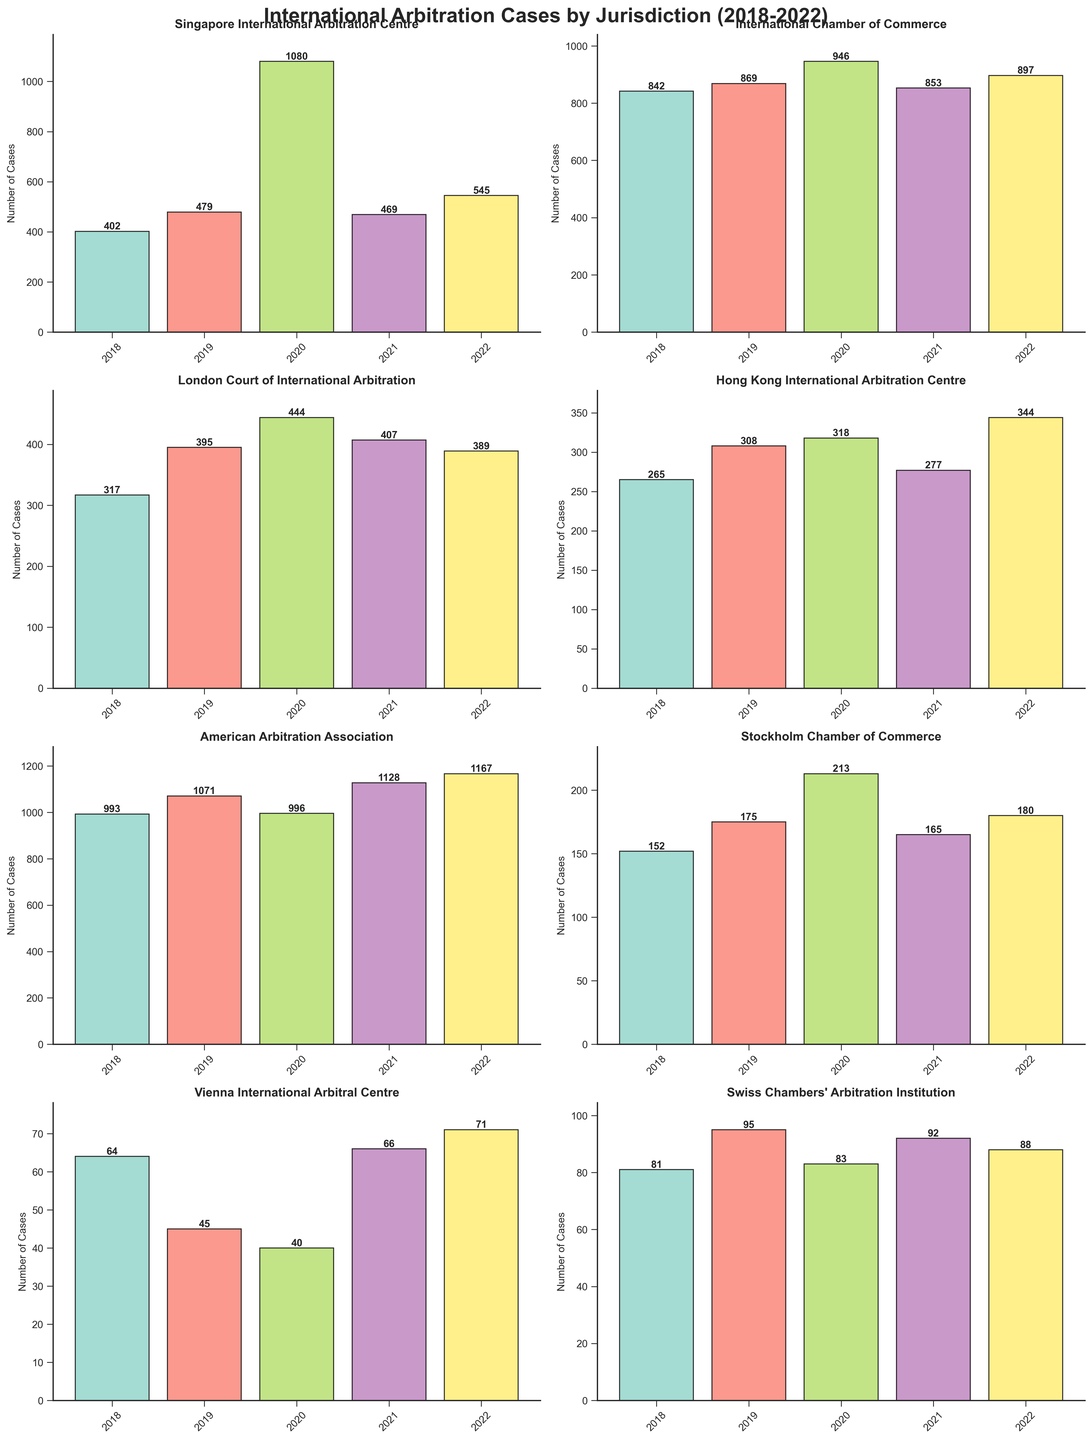What is the title of the figure? The title is usually displayed at the top of the figure. In this case, it is clearly mentioned at the top in bold.
Answer: International Arbitration Cases by Jurisdiction (2018-2022) How many jurisdictions are depicted in the figure? Each subplot represents a different jurisdiction. By counting the number of subplots, we can determine the number of jurisdictions.
Answer: 8 Which jurisdiction had the highest number of arbitration cases in 2022? By examining the 2022 bars in each subplot, the jurisdiction with the highest bar indicates the highest number of arbitration cases.
Answer: American Arbitration Association Which jurisdiction showed the most significant increase in cases from 2019 to 2020? We compare the heights of the bars for 2019 and 2020 for each jurisdiction. The jurisdiction with the largest difference (increase) between these two years shows the most significant increase.
Answer: Singapore International Arbitration Centre What is the average number of cases for the London Court of International Arbitration over the 5 years? To find the average, add the number of cases for each year for the London Court of International Arbitration and divide by 5. The values are 317, 395, 444, 407, and 389. So, (317 + 395 + 444 + 407 + 389) / 5 = 1952 / 5 = 390.4
Answer: 390.4 Which jurisdiction had the lowest number of arbitration cases in 2020? By looking at the 2020 bars in each subplot, the jurisdiction with the smallest bar height represents the lowest number of arbitration cases.
Answer: Vienna International Arbitral Centre Did the Stockholm Chamber of Commerce see a continuous increase in the number of cases from 2018 to 2022? We need to check the heights of the bars for the Stockholm Chamber of Commerce from 2018 to 2022 and see if they continuously increased each year. The values are 152 in 2018, 175 in 2019, 213 in 2020, 165 in 2021, and 180 in 2022. There is a drop from 2020 to 2021.
Answer: No Between the International Chamber of Commerce and the Hong Kong International Arbitration Centre, which one had a larger total number of cases from 2018 to 2022? Add the number of cases for each year from 2018 to 2022 for both jurisdictions, then compare the sums. For the International Chamber of Commerce: 842 + 869 + 946 + 853 + 897 = 4407. For the Hong Kong International Arbitration Centre: 265 + 308 + 318 + 277 + 344 = 1512. Clearly, the International Chamber of Commerce has a larger total number.
Answer: International Chamber of Commerce In which year did the Swiss Chambers' Arbitration Institution experience its highest number of arbitration cases? We examine the bar heights for the Swiss Chambers' Arbitration Institution across the years. The highest bar will indicate the year with the highest number of cases.
Answer: 2019 If we rank the jurisdictions based on their number of cases in 2021, which one comes third? We need to order the jurisdictions by their 2021 bar heights in descending order. The order is: American Arbitration Association (1128), International Chamber of Commerce (853), London Court of International Arbitration (407), Singapore International Arbitration Centre (469), Hong Kong International Arbitration Centre (277), Stockholm Chamber of Commerce (165), Swiss Chambers' Arbitration Institution (92), Vienna International Arbitral Centre (66). The third-highest is the London Court of International Arbitration with 407 cases.
Answer: London Court of International Arbitration 